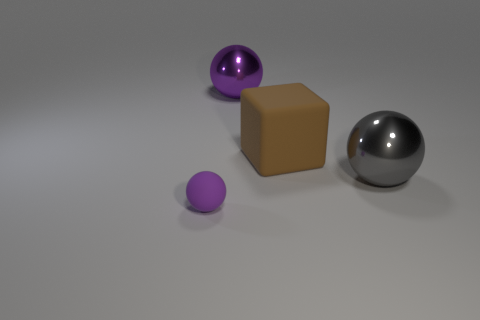The big metal thing that is right of the big shiny sphere that is left of the big sphere that is in front of the purple metallic sphere is what color?
Make the answer very short. Gray. There is a rubber thing that is in front of the gray metallic sphere; what size is it?
Give a very brief answer. Small. How many big objects are cylinders or metallic things?
Your answer should be very brief. 2. There is a object that is both to the right of the matte ball and on the left side of the brown rubber thing; what is its color?
Provide a succinct answer. Purple. Are there any brown matte things that have the same shape as the gray metal thing?
Offer a very short reply. No. What material is the small purple object?
Offer a very short reply. Rubber. Are there any purple balls in front of the big purple metallic sphere?
Your answer should be very brief. Yes. Is the shape of the brown thing the same as the small purple thing?
Provide a succinct answer. No. How many other things are there of the same size as the matte block?
Give a very brief answer. 2. How many objects are either big metal things left of the brown rubber cube or large shiny balls?
Provide a short and direct response. 2. 